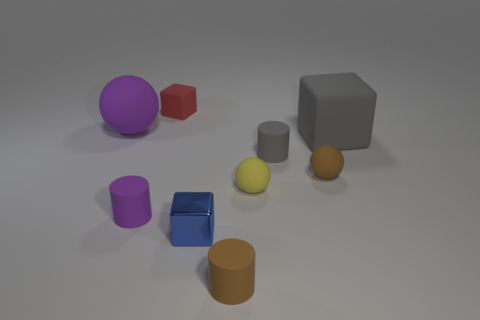Add 1 small blue rubber spheres. How many objects exist? 10 Add 2 large matte blocks. How many large matte blocks are left? 3 Add 6 tiny brown shiny cylinders. How many tiny brown shiny cylinders exist? 6 Subtract all purple balls. How many balls are left? 2 Subtract all tiny spheres. How many spheres are left? 1 Subtract 0 green cylinders. How many objects are left? 9 Subtract all cylinders. How many objects are left? 6 Subtract 1 blocks. How many blocks are left? 2 Subtract all gray cylinders. Subtract all green balls. How many cylinders are left? 2 Subtract all yellow balls. How many gray cylinders are left? 1 